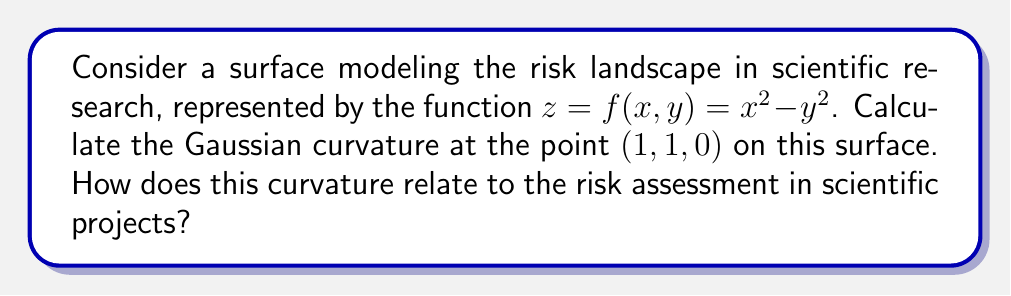What is the answer to this math problem? To calculate the Gaussian curvature, we need to follow these steps:

1. Calculate the first and second partial derivatives of $f(x,y)$:
   $f_x = 2x$, $f_y = -2y$
   $f_{xx} = 2$, $f_{yy} = -2$, $f_{xy} = f_{yx} = 0$

2. Compute the coefficients of the first fundamental form:
   $E = 1 + f_x^2 = 1 + 4x^2$
   $F = f_x f_y = -4xy$
   $G = 1 + f_y^2 = 1 + 4y^2$

3. Compute the coefficients of the second fundamental form:
   $L = \frac{f_{xx}}{\sqrt{1 + f_x^2 + f_y^2}} = \frac{2}{\sqrt{1 + 4x^2 + 4y^2}}$
   $M = \frac{f_{xy}}{\sqrt{1 + f_x^2 + f_y^2}} = 0$
   $N = \frac{f_{yy}}{\sqrt{1 + f_x^2 + f_y^2}} = \frac{-2}{\sqrt{1 + 4x^2 + 4y^2}}$

4. Calculate the Gaussian curvature using the formula:
   $K = \frac{LN - M^2}{EG - F^2}$

5. Substitute the point (1, 1, 0) into the formula:
   $K = \frac{(\frac{2}{\sqrt{9}})(\frac{-2}{\sqrt{9}}) - 0^2}{(5)(5) - (-4)^2} = \frac{-\frac{4}{9}}{25 - 16} = \frac{-4}{81} \approx -0.0494$

The negative Gaussian curvature at (1, 1, 0) indicates a saddle point in the risk landscape. In the context of scientific research and risk assessment, this suggests:

1. The risk landscape is complex and non-uniform.
2. Small changes in project parameters can lead to significant changes in risk levels.
3. Risk mitigation strategies may need to be adaptable and multifaceted.
4. Legal counsel should be prepared for potentially rapid shifts in risk profiles.
Answer: $K = -\frac{4}{81}$; saddle point indicating complex risk landscape 